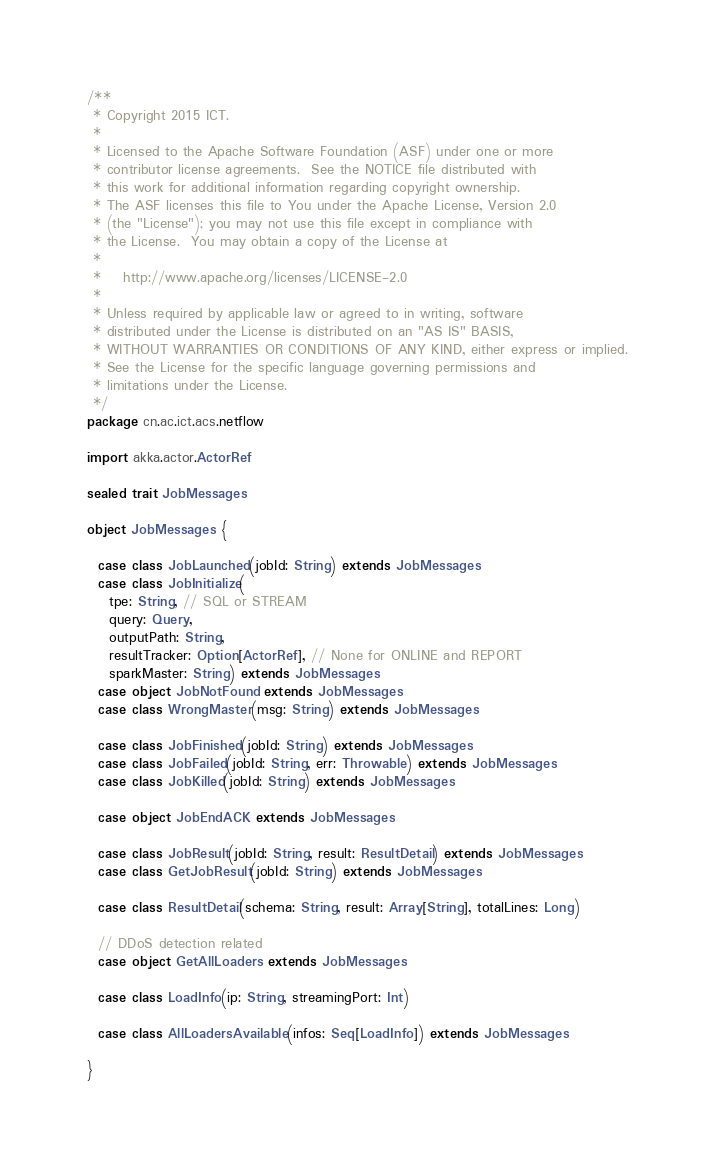Convert code to text. <code><loc_0><loc_0><loc_500><loc_500><_Scala_>/**
 * Copyright 2015 ICT.
 *
 * Licensed to the Apache Software Foundation (ASF) under one or more
 * contributor license agreements.  See the NOTICE file distributed with
 * this work for additional information regarding copyright ownership.
 * The ASF licenses this file to You under the Apache License, Version 2.0
 * (the "License"); you may not use this file except in compliance with
 * the License.  You may obtain a copy of the License at
 *
 *    http://www.apache.org/licenses/LICENSE-2.0
 *
 * Unless required by applicable law or agreed to in writing, software
 * distributed under the License is distributed on an "AS IS" BASIS,
 * WITHOUT WARRANTIES OR CONDITIONS OF ANY KIND, either express or implied.
 * See the License for the specific language governing permissions and
 * limitations under the License.
 */
package cn.ac.ict.acs.netflow

import akka.actor.ActorRef

sealed trait JobMessages

object JobMessages {

  case class JobLaunched(jobId: String) extends JobMessages
  case class JobInitialize(
    tpe: String, // SQL or STREAM
    query: Query,
    outputPath: String,
    resultTracker: Option[ActorRef], // None for ONLINE and REPORT
    sparkMaster: String) extends JobMessages
  case object JobNotFound extends JobMessages
  case class WrongMaster(msg: String) extends JobMessages

  case class JobFinished(jobId: String) extends JobMessages
  case class JobFailed(jobId: String, err: Throwable) extends JobMessages
  case class JobKilled(jobId: String) extends JobMessages

  case object JobEndACK extends JobMessages

  case class JobResult(jobId: String, result: ResultDetail) extends JobMessages
  case class GetJobResult(jobId: String) extends JobMessages

  case class ResultDetail(schema: String, result: Array[String], totalLines: Long)

  // DDoS detection related
  case object GetAllLoaders extends JobMessages

  case class LoadInfo(ip: String, streamingPort: Int)

  case class AllLoadersAvailable(infos: Seq[LoadInfo]) extends JobMessages

}
</code> 